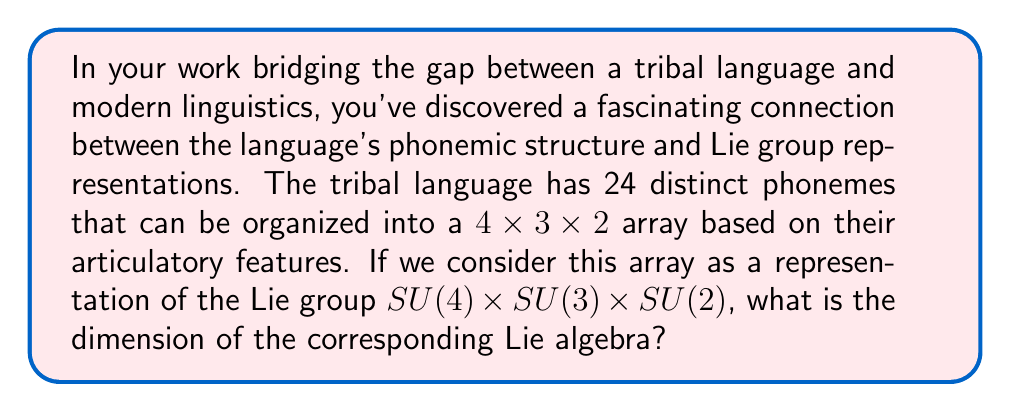Can you answer this question? To solve this problem, we need to understand the connection between Lie groups and their associated Lie algebras. The dimension of a Lie algebra is equal to the dimension of the corresponding Lie group as a manifold. 

Let's break down the problem step-by-step:

1. We are dealing with the Lie group $SU(4) \times SU(3) \times SU(2)$. This is a product of three special unitary groups.

2. For a special unitary group $SU(n)$, the dimension of its Lie algebra $\mathfrak{su}(n)$ is given by $n^2 - 1$. This is because $SU(n)$ consists of $n \times n$ unitary matrices with determinant 1, and the condition of unit determinant reduces the degrees of freedom by 1.

3. Let's calculate the dimensions for each component:
   - For $SU(4)$: $\dim(\mathfrak{su}(4)) = 4^2 - 1 = 15$
   - For $SU(3)$: $\dim(\mathfrak{su}(3)) = 3^2 - 1 = 8$
   - For $SU(2)$: $\dim(\mathfrak{su}(2)) = 2^2 - 1 = 3$

4. The Lie algebra of a product of Lie groups is the direct sum of their individual Lie algebras. Therefore, the dimension of the total Lie algebra is the sum of the dimensions of the component Lie algebras.

5. Thus, the total dimension is:

   $$\dim(\mathfrak{su}(4) \oplus \mathfrak{su}(3) \oplus \mathfrak{su}(2)) = 15 + 8 + 3 = 26$$

This result shows that the 24 phonemes of the tribal language, when organized into a 4x3x2 array, can be associated with a 26-dimensional Lie algebra representation. The additional dimensions might correspond to suprasegmental features or other linguistic aspects not captured by the basic phonemic inventory.
Answer: The dimension of the corresponding Lie algebra is 26. 